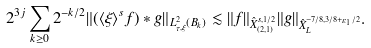<formula> <loc_0><loc_0><loc_500><loc_500>2 ^ { 3 j } \sum _ { k \geq 0 } 2 ^ { - k / 2 } \| ( \langle \xi \rangle ^ { s } f ) * g \| _ { L _ { \tau , \xi } ^ { 2 } ( B _ { k } ) } \lesssim \| f \| _ { \hat { X } _ { ( 2 , 1 ) } ^ { s , 1 / 2 } } \| g \| _ { \hat { X } _ { L } ^ { - 7 / 8 , 3 / 8 + \varepsilon _ { 1 } / 2 } } .</formula> 